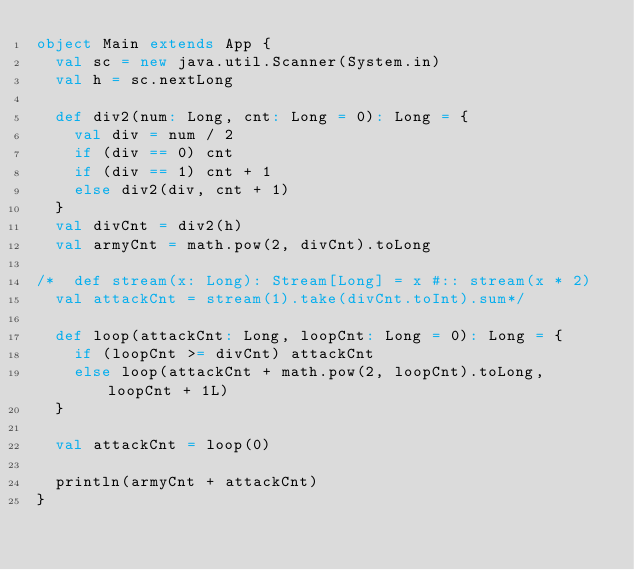Convert code to text. <code><loc_0><loc_0><loc_500><loc_500><_Scala_>object Main extends App {
  val sc = new java.util.Scanner(System.in)
  val h = sc.nextLong
  
  def div2(num: Long, cnt: Long = 0): Long = {
    val div = num / 2
    if (div == 0) cnt
    if (div == 1) cnt + 1
    else div2(div, cnt + 1)
  }
  val divCnt = div2(h)
  val armyCnt = math.pow(2, divCnt).toLong

/*  def stream(x: Long): Stream[Long] = x #:: stream(x * 2)
  val attackCnt = stream(1).take(divCnt.toInt).sum*/

  def loop(attackCnt: Long, loopCnt: Long = 0): Long = {
    if (loopCnt >= divCnt) attackCnt
    else loop(attackCnt + math.pow(2, loopCnt).toLong, loopCnt + 1L)
  }
  
  val attackCnt = loop(0)
  
  println(armyCnt + attackCnt)
}</code> 